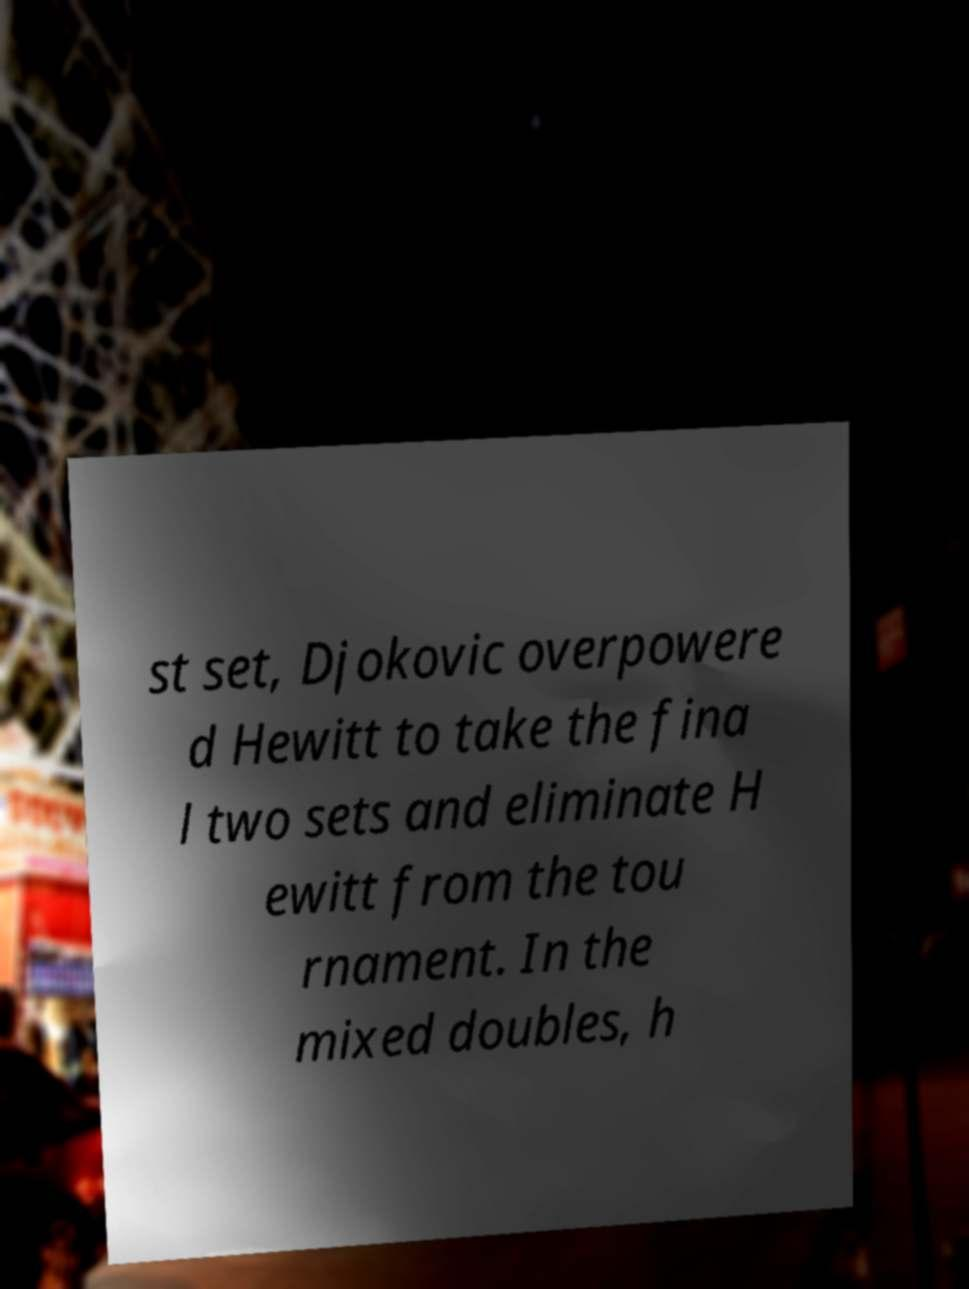Could you extract and type out the text from this image? st set, Djokovic overpowere d Hewitt to take the fina l two sets and eliminate H ewitt from the tou rnament. In the mixed doubles, h 